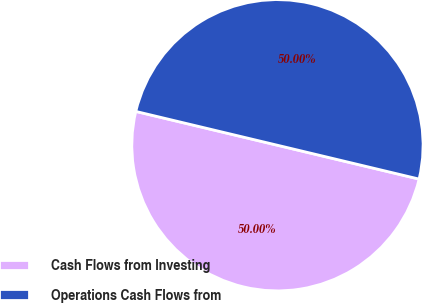Convert chart. <chart><loc_0><loc_0><loc_500><loc_500><pie_chart><fcel>Cash Flows from Investing<fcel>Operations Cash Flows from<nl><fcel>50.0%<fcel>50.0%<nl></chart> 